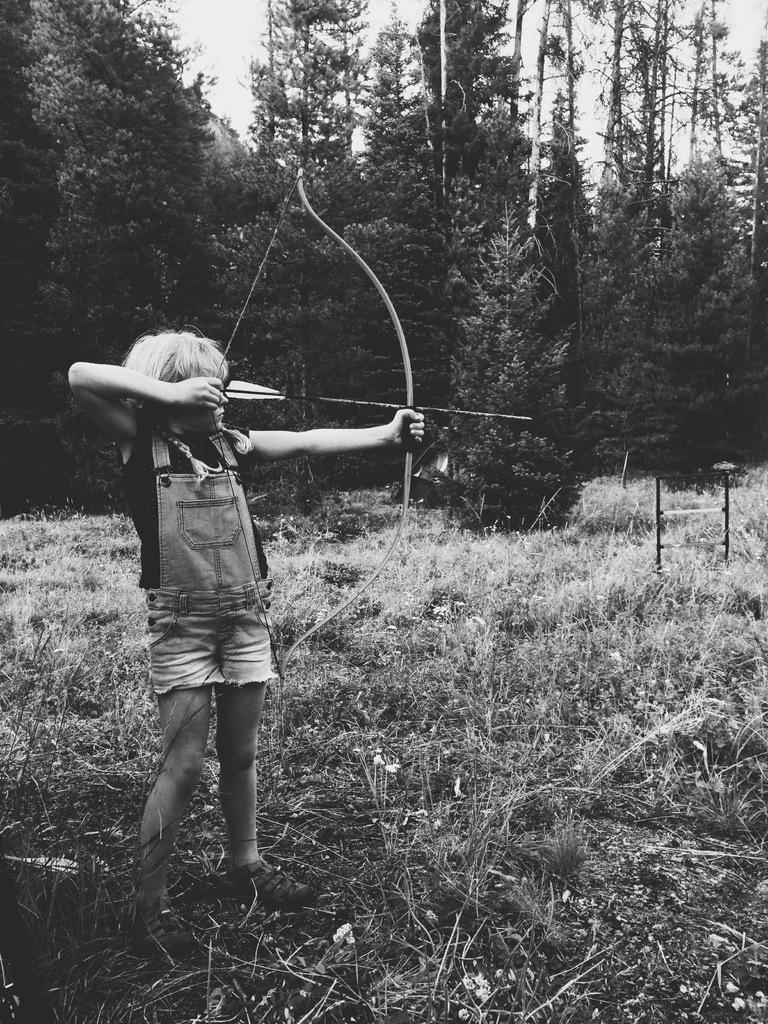What is the color scheme of the image? The image is black and white. What is the main subject of the image? There is a kid in the image. What is the kid doing in the image? The kid is arrowing. What type of terrain is visible in the image? There is grass on the ground in the image. What can be seen in the background of the image? There are trees in the background of the image. What type of vase is present on the grass in the image? There is no vase present on the grass in the image. What type of treatment is the kid receiving in the image? The image does not depict any treatment being administered to the kid; the kid is arrowing. 